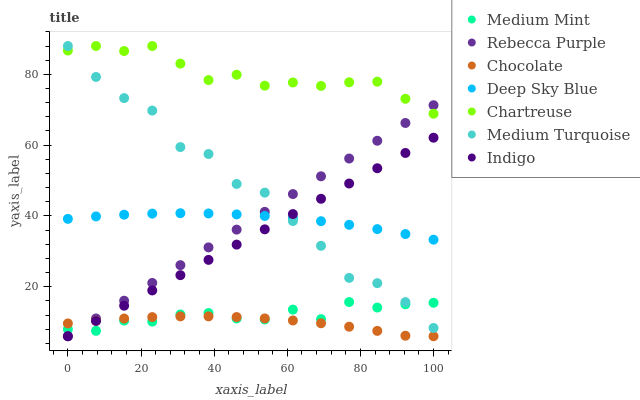Does Chocolate have the minimum area under the curve?
Answer yes or no. Yes. Does Chartreuse have the maximum area under the curve?
Answer yes or no. Yes. Does Indigo have the minimum area under the curve?
Answer yes or no. No. Does Indigo have the maximum area under the curve?
Answer yes or no. No. Is Rebecca Purple the smoothest?
Answer yes or no. Yes. Is Medium Turquoise the roughest?
Answer yes or no. Yes. Is Indigo the smoothest?
Answer yes or no. No. Is Indigo the roughest?
Answer yes or no. No. Does Indigo have the lowest value?
Answer yes or no. Yes. Does Deep Sky Blue have the lowest value?
Answer yes or no. No. Does Medium Turquoise have the highest value?
Answer yes or no. Yes. Does Indigo have the highest value?
Answer yes or no. No. Is Chocolate less than Chartreuse?
Answer yes or no. Yes. Is Chartreuse greater than Indigo?
Answer yes or no. Yes. Does Medium Mint intersect Medium Turquoise?
Answer yes or no. Yes. Is Medium Mint less than Medium Turquoise?
Answer yes or no. No. Is Medium Mint greater than Medium Turquoise?
Answer yes or no. No. Does Chocolate intersect Chartreuse?
Answer yes or no. No. 